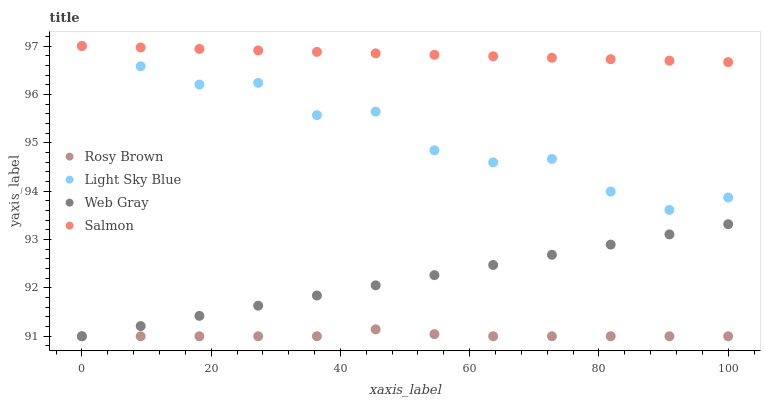Does Rosy Brown have the minimum area under the curve?
Answer yes or no. Yes. Does Salmon have the maximum area under the curve?
Answer yes or no. Yes. Does Web Gray have the minimum area under the curve?
Answer yes or no. No. Does Web Gray have the maximum area under the curve?
Answer yes or no. No. Is Salmon the smoothest?
Answer yes or no. Yes. Is Light Sky Blue the roughest?
Answer yes or no. Yes. Is Rosy Brown the smoothest?
Answer yes or no. No. Is Rosy Brown the roughest?
Answer yes or no. No. Does Rosy Brown have the lowest value?
Answer yes or no. Yes. Does Light Sky Blue have the lowest value?
Answer yes or no. No. Does Light Sky Blue have the highest value?
Answer yes or no. Yes. Does Web Gray have the highest value?
Answer yes or no. No. Is Web Gray less than Light Sky Blue?
Answer yes or no. Yes. Is Light Sky Blue greater than Rosy Brown?
Answer yes or no. Yes. Does Salmon intersect Light Sky Blue?
Answer yes or no. Yes. Is Salmon less than Light Sky Blue?
Answer yes or no. No. Is Salmon greater than Light Sky Blue?
Answer yes or no. No. Does Web Gray intersect Light Sky Blue?
Answer yes or no. No. 